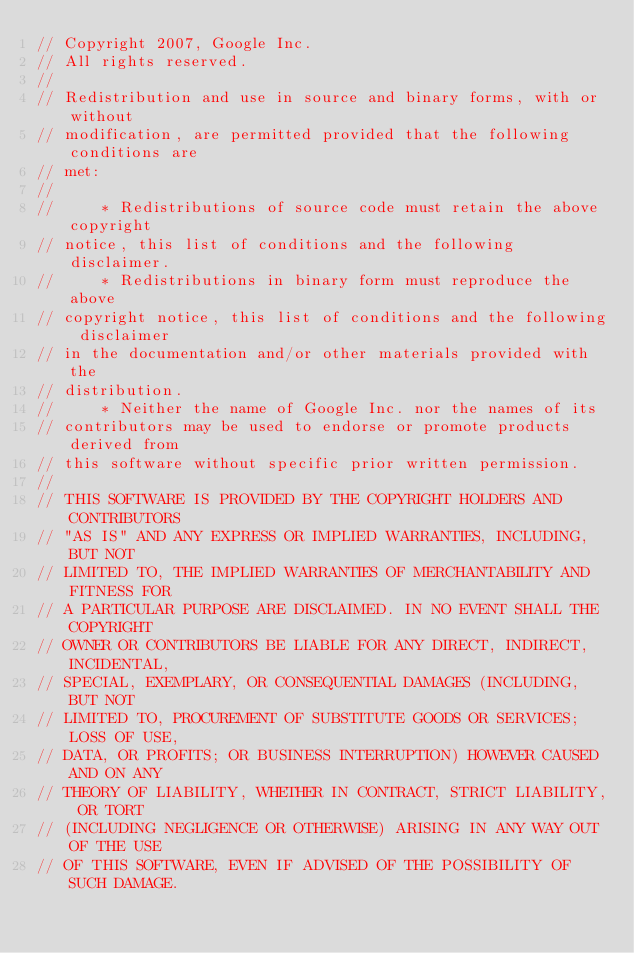Convert code to text. <code><loc_0><loc_0><loc_500><loc_500><_C++_>// Copyright 2007, Google Inc.
// All rights reserved.
//
// Redistribution and use in source and binary forms, with or without
// modification, are permitted provided that the following conditions are
// met:
//
//     * Redistributions of source code must retain the above copyright
// notice, this list of conditions and the following disclaimer.
//     * Redistributions in binary form must reproduce the above
// copyright notice, this list of conditions and the following disclaimer
// in the documentation and/or other materials provided with the
// distribution.
//     * Neither the name of Google Inc. nor the names of its
// contributors may be used to endorse or promote products derived from
// this software without specific prior written permission.
//
// THIS SOFTWARE IS PROVIDED BY THE COPYRIGHT HOLDERS AND CONTRIBUTORS
// "AS IS" AND ANY EXPRESS OR IMPLIED WARRANTIES, INCLUDING, BUT NOT
// LIMITED TO, THE IMPLIED WARRANTIES OF MERCHANTABILITY AND FITNESS FOR
// A PARTICULAR PURPOSE ARE DISCLAIMED. IN NO EVENT SHALL THE COPYRIGHT
// OWNER OR CONTRIBUTORS BE LIABLE FOR ANY DIRECT, INDIRECT, INCIDENTAL,
// SPECIAL, EXEMPLARY, OR CONSEQUENTIAL DAMAGES (INCLUDING, BUT NOT
// LIMITED TO, PROCUREMENT OF SUBSTITUTE GOODS OR SERVICES; LOSS OF USE,
// DATA, OR PROFITS; OR BUSINESS INTERRUPTION) HOWEVER CAUSED AND ON ANY
// THEORY OF LIABILITY, WHETHER IN CONTRACT, STRICT LIABILITY, OR TORT
// (INCLUDING NEGLIGENCE OR OTHERWISE) ARISING IN ANY WAY OUT OF THE USE
// OF THIS SOFTWARE, EVEN IF ADVISED OF THE POSSIBILITY OF SUCH DAMAGE.
</code> 